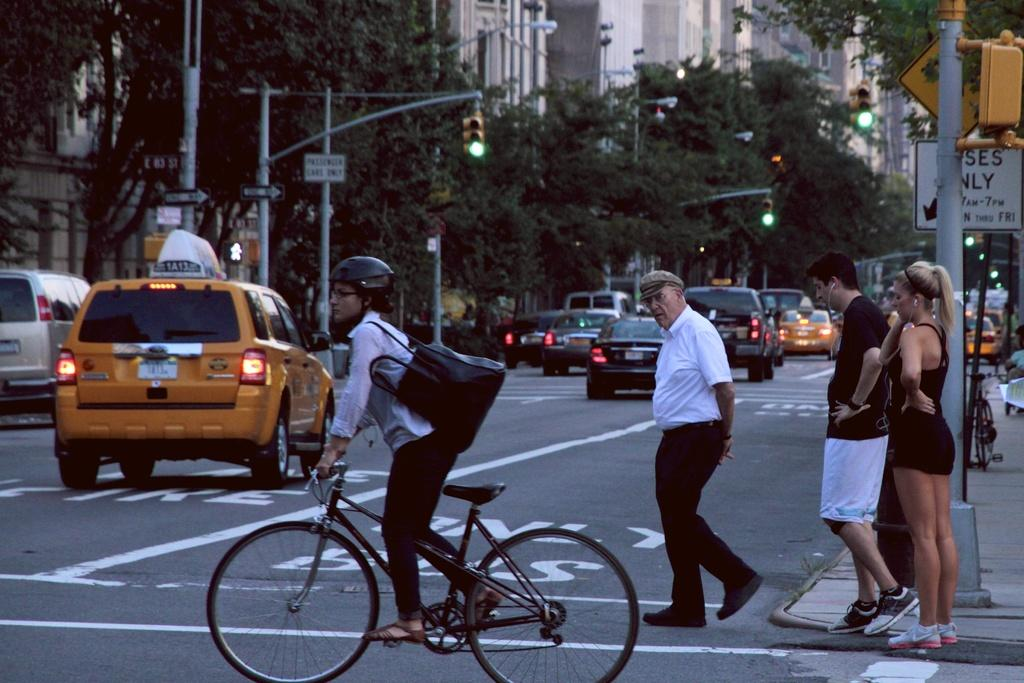What type of structures can be seen in the image? There are buildings in the image. What else can be seen in the image besides buildings? There are trees, a traffic signal, cars, people walking on the road, and a bicycle in the image. Can you describe the mode of transportation used by some people in the image? Some people are walking on the road, while others are using cars and a bicycle for transportation. How many sisters are laughing together in the image? There are no sisters or laughter depicted in the image. 